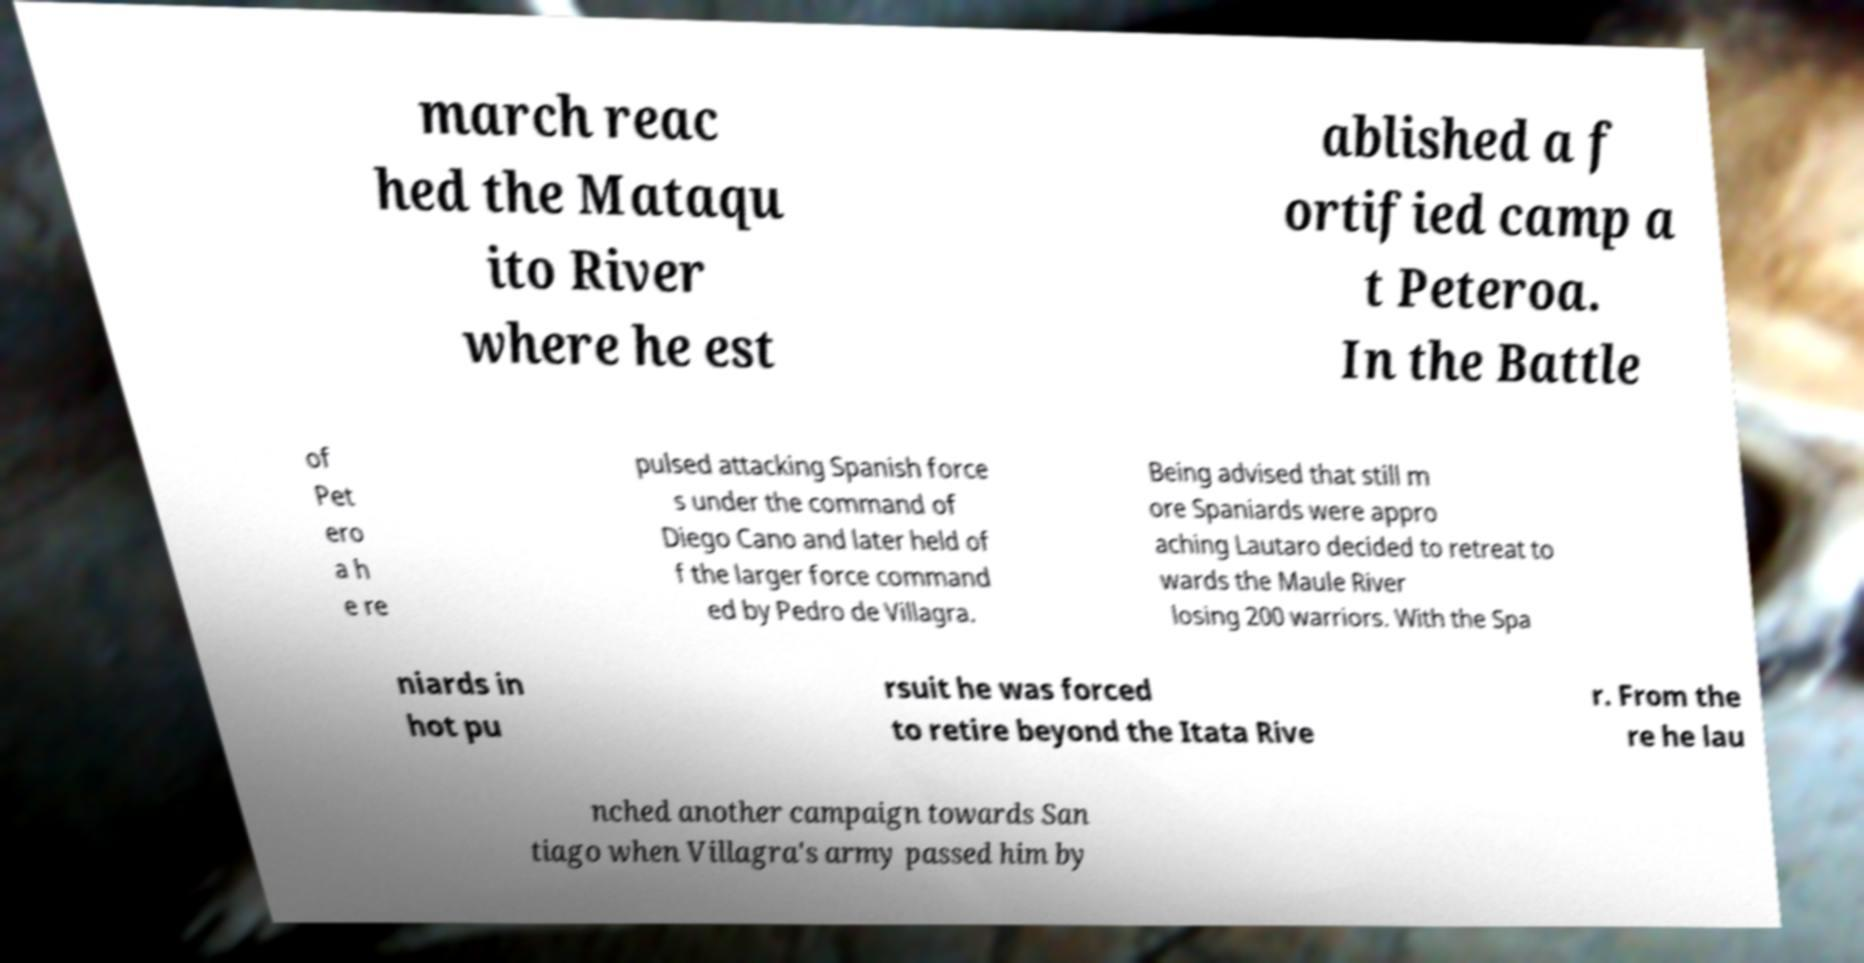For documentation purposes, I need the text within this image transcribed. Could you provide that? march reac hed the Mataqu ito River where he est ablished a f ortified camp a t Peteroa. In the Battle of Pet ero a h e re pulsed attacking Spanish force s under the command of Diego Cano and later held of f the larger force command ed by Pedro de Villagra. Being advised that still m ore Spaniards were appro aching Lautaro decided to retreat to wards the Maule River losing 200 warriors. With the Spa niards in hot pu rsuit he was forced to retire beyond the Itata Rive r. From the re he lau nched another campaign towards San tiago when Villagra's army passed him by 